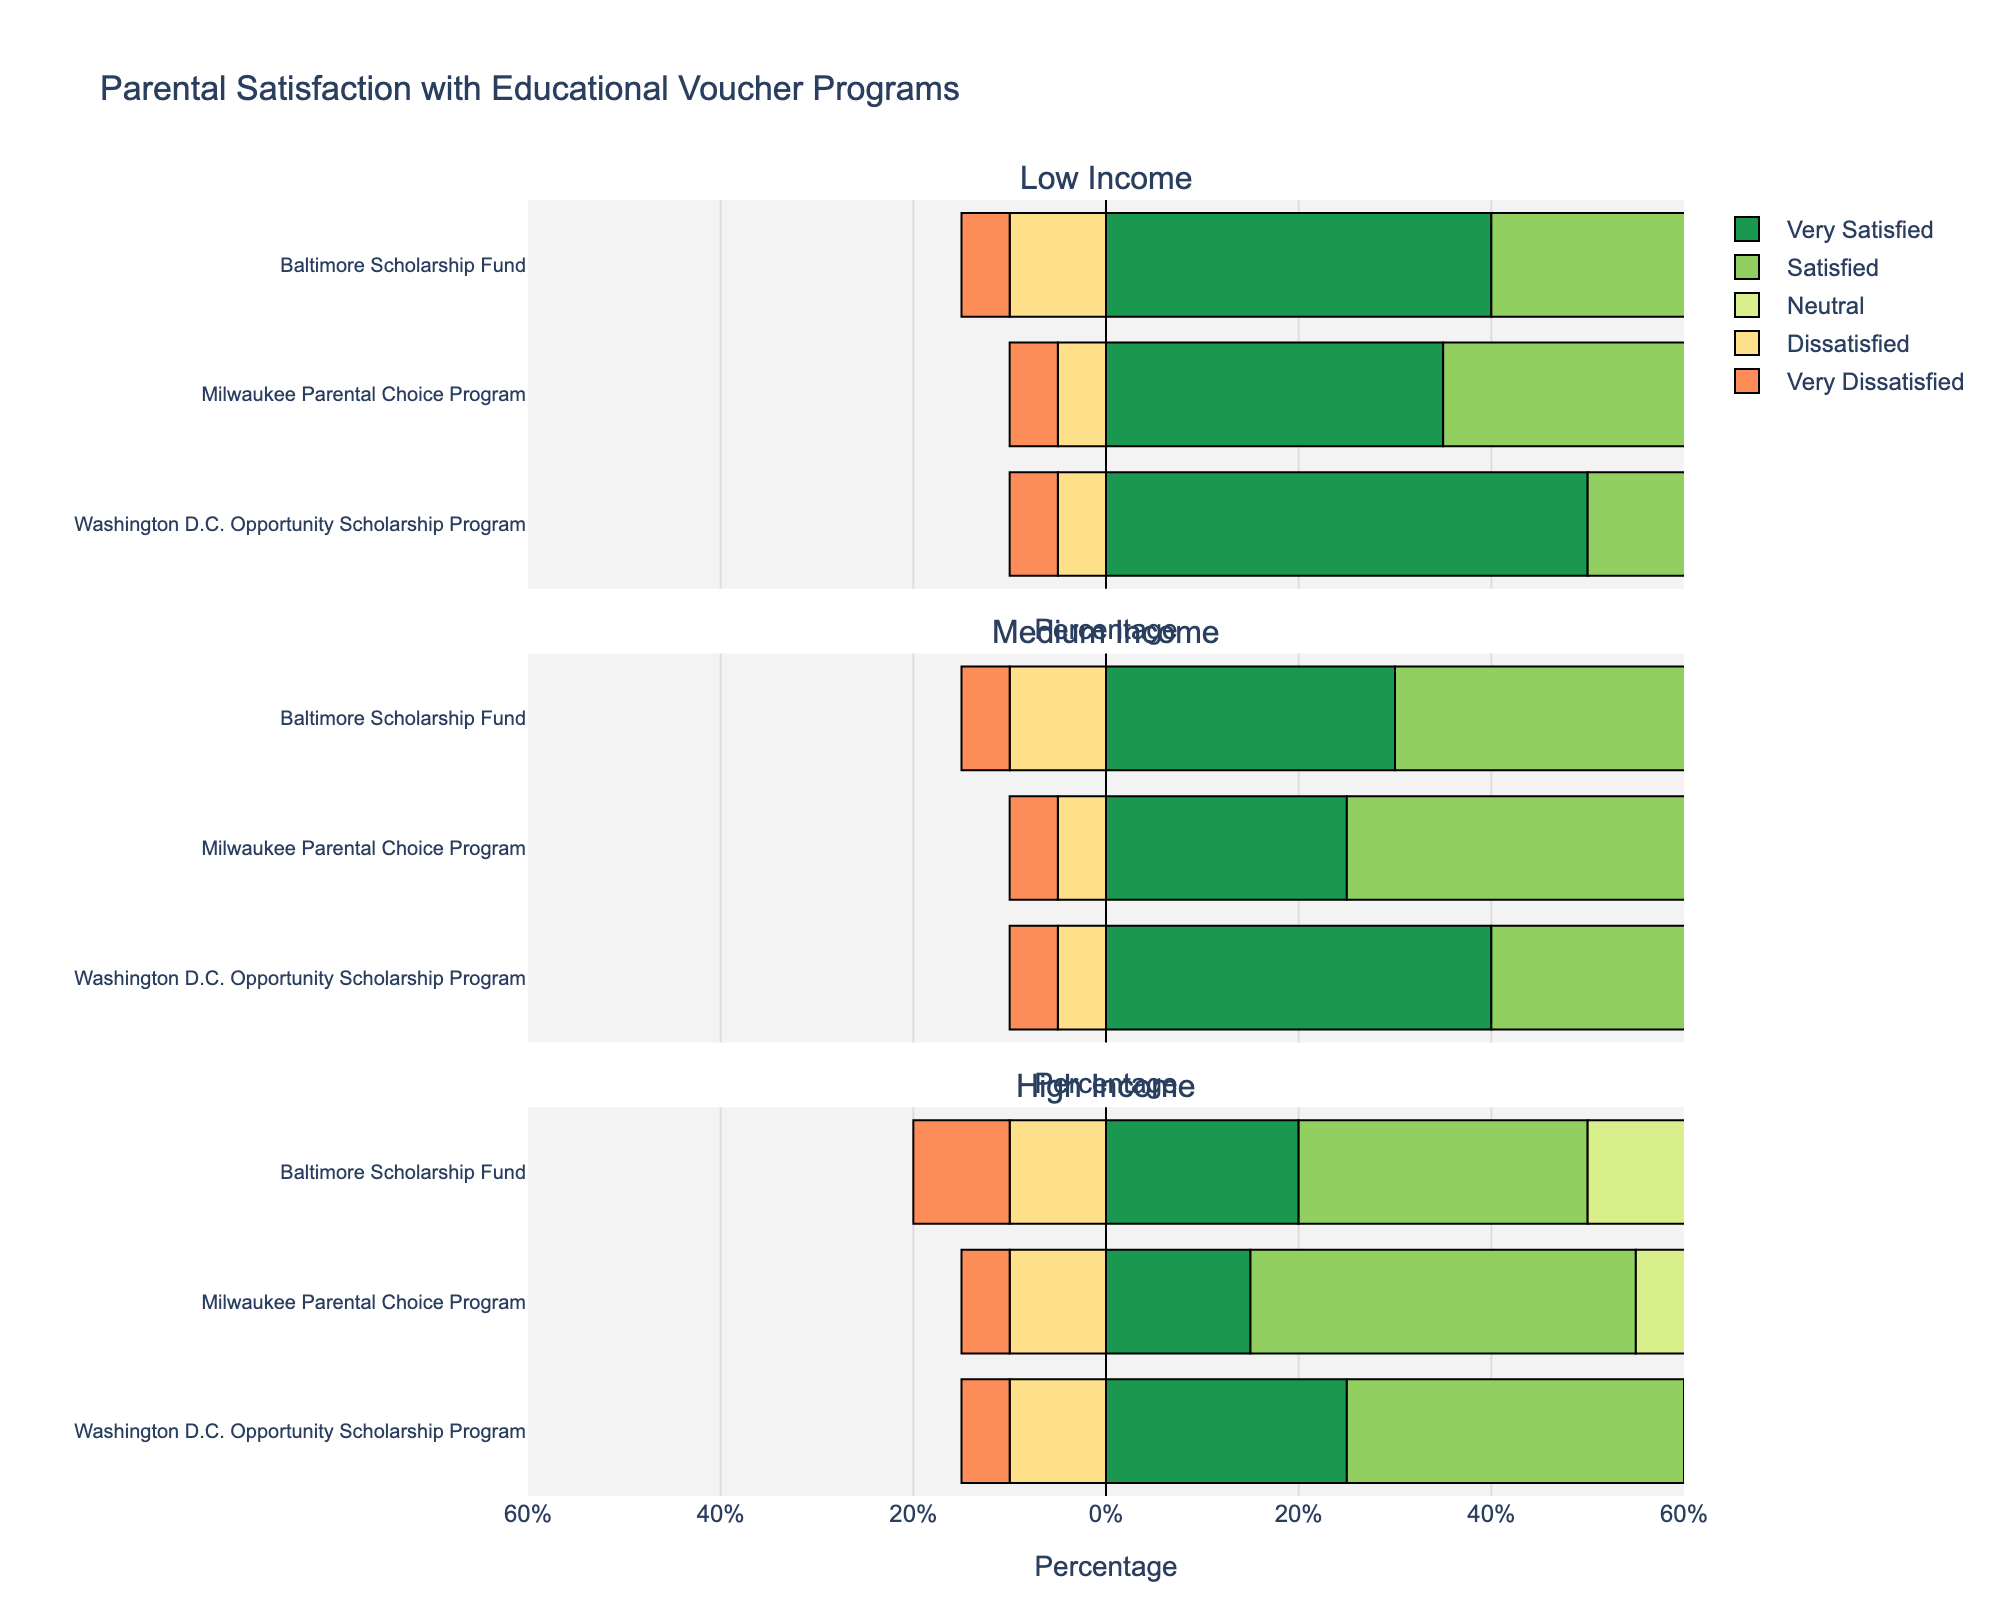Which income level shows the highest percentage of "Very Satisfied" parents with the Washington D.C. Opportunity Scholarship Program? By looking at the horizontal bars representing "Very Satisfied" for the Washington D.C. Opportunity Scholarship Program across low, medium, and high-income levels, it's evident which bar is the longest. The low-income level shows the longest bar, indicating the highest percentage.
Answer: Low-income level What is the total percentage of parents who are either "Dissatisfied" or "Very Dissatisfied" with the Baltimore Scholarship Fund across all income levels? To find this, sum the percentages of "Dissatisfied" and "Very Dissatisfied" parents for the Baltimore Scholarship Fund in each income level and then add them up: (10+5) for Low, (10+5) for Medium, and (10+10) for High, which is 15 + 15 + 20 = 50%.
Answer: 50% Compare the satisfaction levels between the Milwaukee Parental Choice Program and the Baltimore Scholarship Fund for the Medium-income level. Which program has a higher combined percentage of "Very Satisfied" and "Satisfied" parents? For the Medium-income level, add "Very Satisfied" and "Satisfied" percentages for each program: Milwaukee Parental Choice Program (25+40) = 65% and Baltimore Scholarship Fund (30+35) = 65%. Both are equal.
Answer: Both are equal Which educational voucher program has the highest percentage of "Neutral" responses from parents in the High-income level? By examining the "Neutral" bars in the High-income level for each program, the Milwaukee Parental Choice Program shows the longest bar, indicating the highest percentage.
Answer: Milwaukee Parental Choice Program In the Low-income level, what is the difference in the percentage of parents who are "Very Satisfied" between the Baltimore Scholarship Fund and the Washington D.C. Opportunity Scholarship Program? Subtract the percentage of "Very Satisfied" parents in the Baltimore Scholarship Fund (40%) from the percentage in the Washington D.C. Opportunity Scholarship Program (50%): 50% - 40% = 10%.
Answer: 10% What is the percentage of "Dissatisfied" parents with the Washington D.C. Opportunity Scholarship Program in the Medium-income level compared to the High-income level? Look at the "Dissatisfied" bars for the Washington D.C. Opportunity Scholarship Program in both income levels: Medium is 5% and High is 10%.
Answer: Medium is lower by 5% Among the Low, Medium, and High-income levels, which one shows the highest combined percentage of "Dissatisfied" and "Very Dissatisfied" parents with the Milwaukee Parental Choice Program? Combine "Dissatisfied" and "Very Dissatisfied" for the Milwaukee Parental Choice Program in each income level and compare them: Low is (5+5) = 10%, Medium is (5+5) = 10%, High is (10+5) = 15%. The High-income level is the highest.
Answer: High-income level 